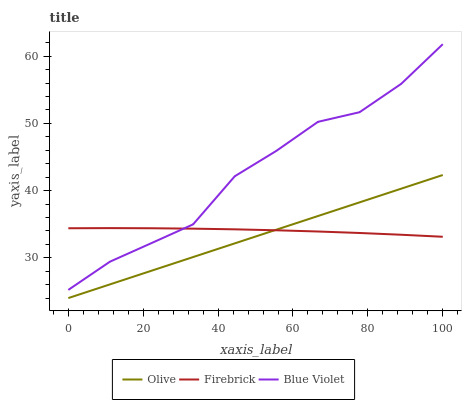Does Olive have the minimum area under the curve?
Answer yes or no. Yes. Does Blue Violet have the maximum area under the curve?
Answer yes or no. Yes. Does Firebrick have the minimum area under the curve?
Answer yes or no. No. Does Firebrick have the maximum area under the curve?
Answer yes or no. No. Is Olive the smoothest?
Answer yes or no. Yes. Is Blue Violet the roughest?
Answer yes or no. Yes. Is Firebrick the smoothest?
Answer yes or no. No. Is Firebrick the roughest?
Answer yes or no. No. Does Blue Violet have the lowest value?
Answer yes or no. No. Does Firebrick have the highest value?
Answer yes or no. No. Is Olive less than Blue Violet?
Answer yes or no. Yes. Is Blue Violet greater than Olive?
Answer yes or no. Yes. Does Olive intersect Blue Violet?
Answer yes or no. No. 